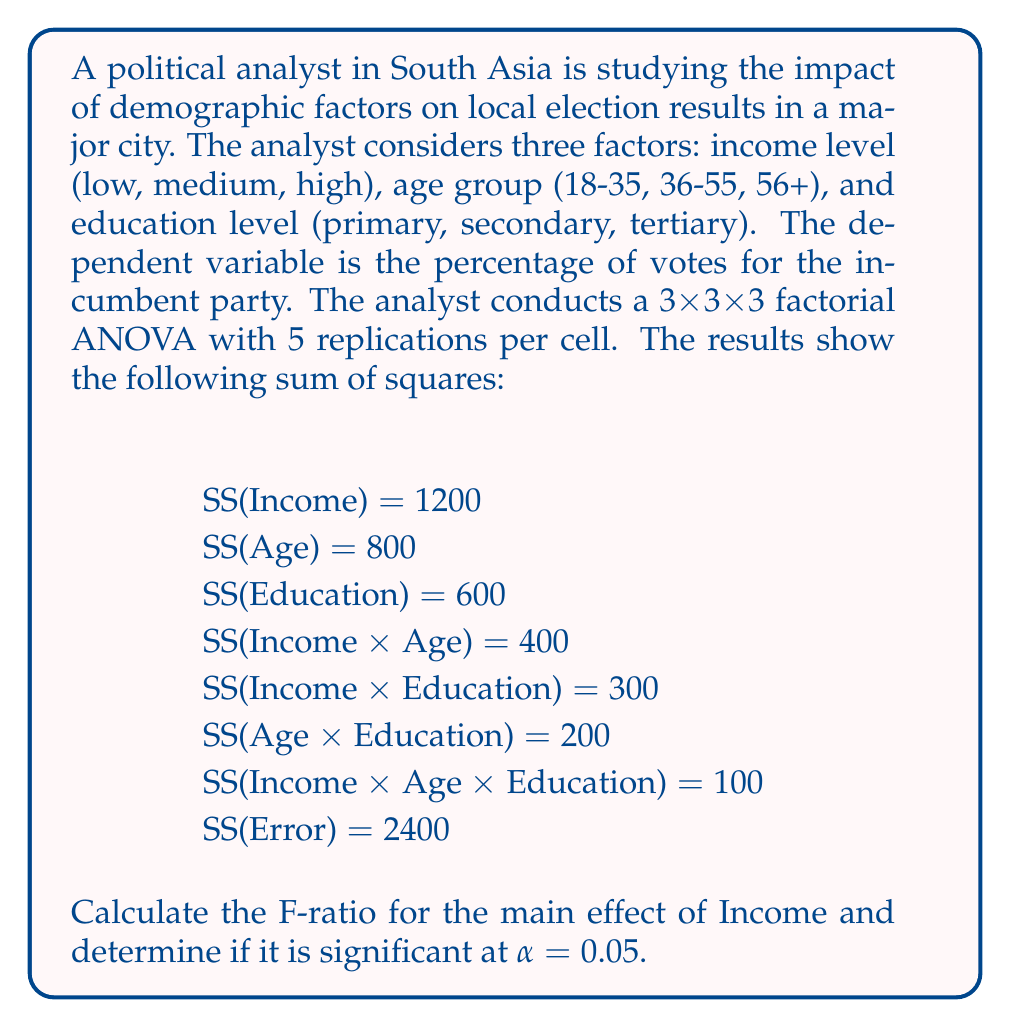What is the answer to this math problem? To solve this problem, we need to follow these steps:

1. Calculate the degrees of freedom (df) for each source of variation:
   - df(Income) = 3 - 1 = 2
   - df(Error) = 3 x 3 x 3 x (5 - 1) = 108

2. Calculate the Mean Square (MS) for Income and Error:
   $$ MS_{Income} = \frac{SS_{Income}}{df_{Income}} = \frac{1200}{2} = 600 $$
   $$ MS_{Error} = \frac{SS_{Error}}{df_{Error}} = \frac{2400}{108} \approx 22.22 $$

3. Calculate the F-ratio:
   $$ F = \frac{MS_{Income}}{MS_{Error}} = \frac{600}{22.22} \approx 27.00 $$

4. Determine the critical F-value:
   For α = 0.05, df₁ = 2, and df₂ = 108, the critical F-value is approximately 3.08 (obtained from an F-distribution table or calculator).

5. Compare the calculated F-ratio to the critical F-value:
   Since 27.00 > 3.08, we reject the null hypothesis.

Therefore, the main effect of Income is statistically significant at α = 0.05.
Answer: F-ratio for Income: 27.00 (rounded to two decimal places)
The main effect of Income is statistically significant at α = 0.05. 